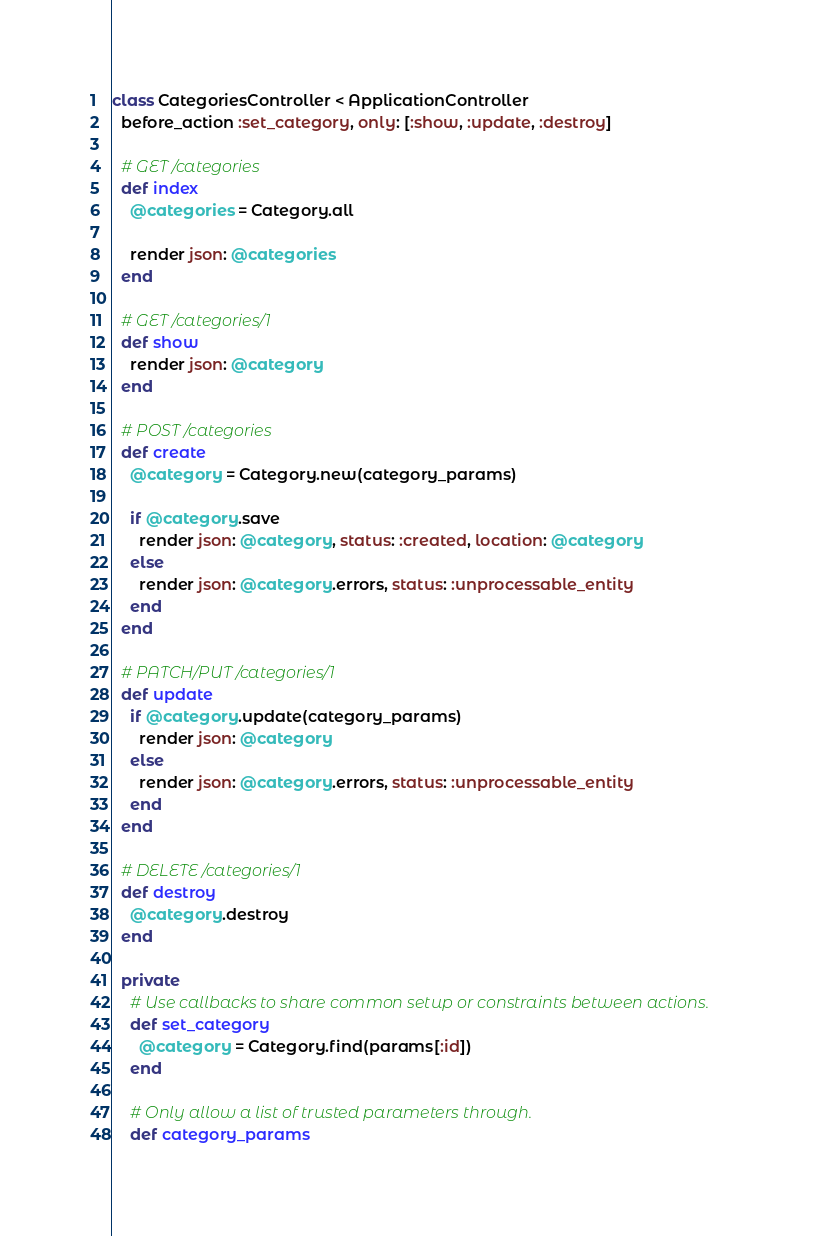<code> <loc_0><loc_0><loc_500><loc_500><_Ruby_>class CategoriesController < ApplicationController
  before_action :set_category, only: [:show, :update, :destroy]

  # GET /categories
  def index
    @categories = Category.all

    render json: @categories
  end

  # GET /categories/1
  def show
    render json: @category
  end

  # POST /categories
  def create
    @category = Category.new(category_params)

    if @category.save
      render json: @category, status: :created, location: @category
    else
      render json: @category.errors, status: :unprocessable_entity
    end
  end

  # PATCH/PUT /categories/1
  def update
    if @category.update(category_params)
      render json: @category
    else
      render json: @category.errors, status: :unprocessable_entity
    end
  end

  # DELETE /categories/1
  def destroy
    @category.destroy
  end

  private
    # Use callbacks to share common setup or constraints between actions.
    def set_category
      @category = Category.find(params[:id])
    end

    # Only allow a list of trusted parameters through.
    def category_params</code> 